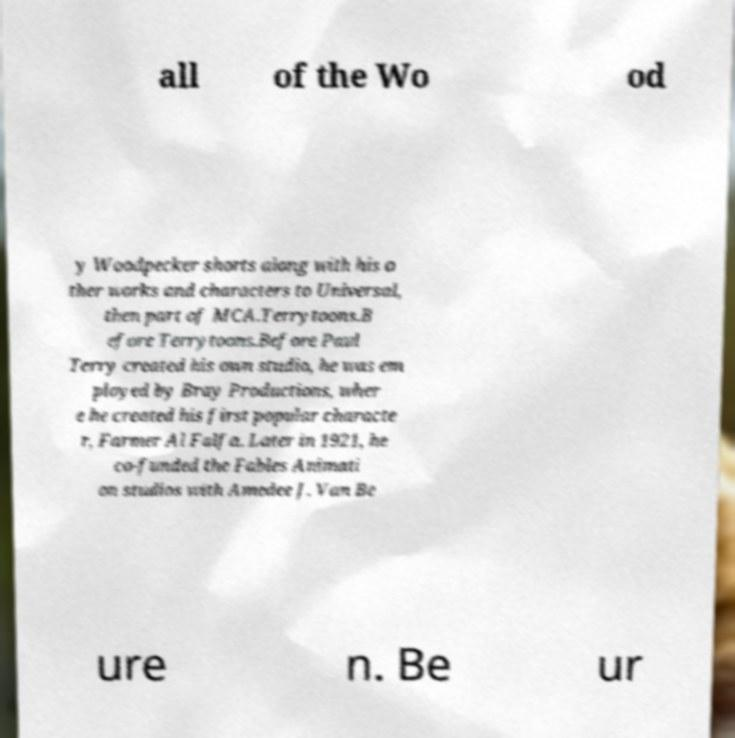Could you extract and type out the text from this image? all of the Wo od y Woodpecker shorts along with his o ther works and characters to Universal, then part of MCA.Terrytoons.B efore Terrytoons.Before Paul Terry created his own studio, he was em ployed by Bray Productions, wher e he created his first popular characte r, Farmer Al Falfa. Later in 1921, he co-funded the Fables Animati on studios with Amedee J. Van Be ure n. Be ur 